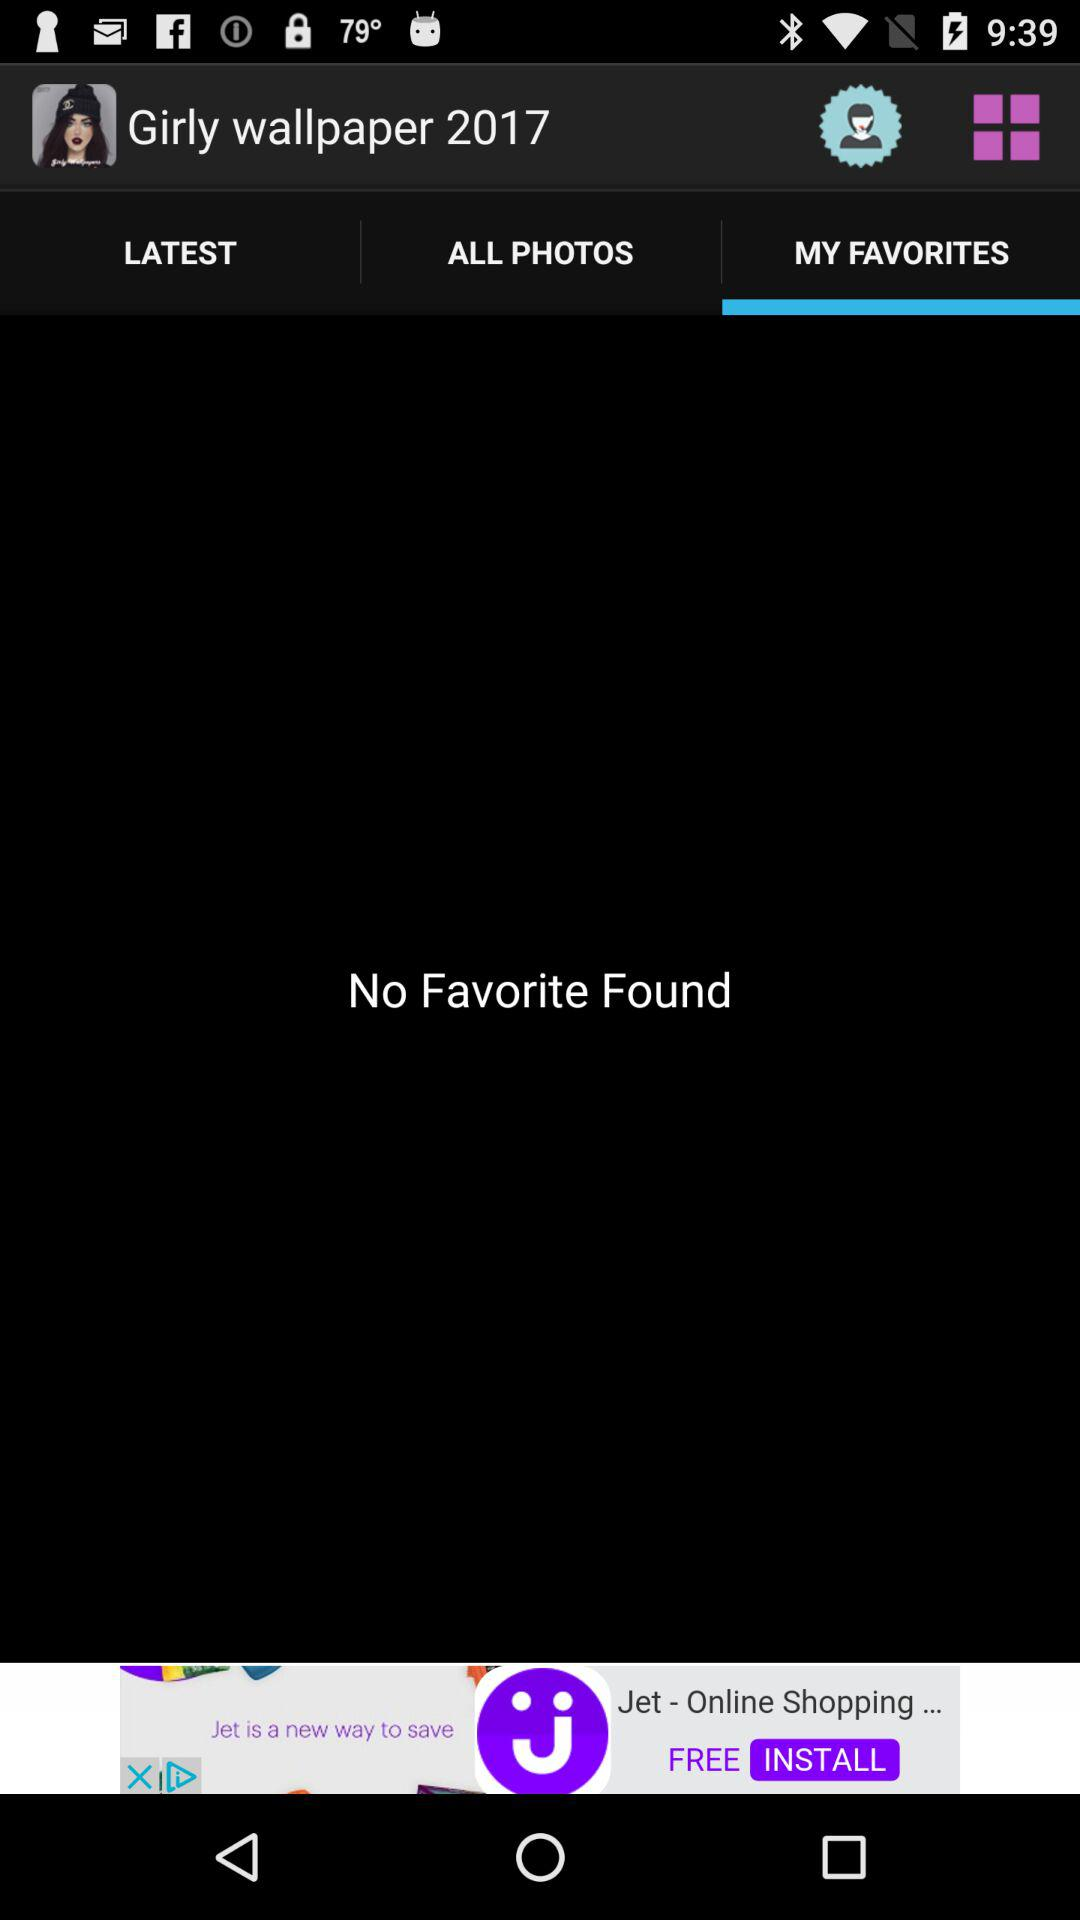How many notifications are there in "LATEST"?
When the provided information is insufficient, respond with <no answer>. <no answer> 